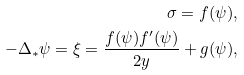Convert formula to latex. <formula><loc_0><loc_0><loc_500><loc_500>\sigma = f ( \psi ) , \\ - \Delta _ { * } \psi = \xi = \frac { f ( \psi ) f ^ { \prime } ( \psi ) } { 2 y } + g ( \psi ) ,</formula> 